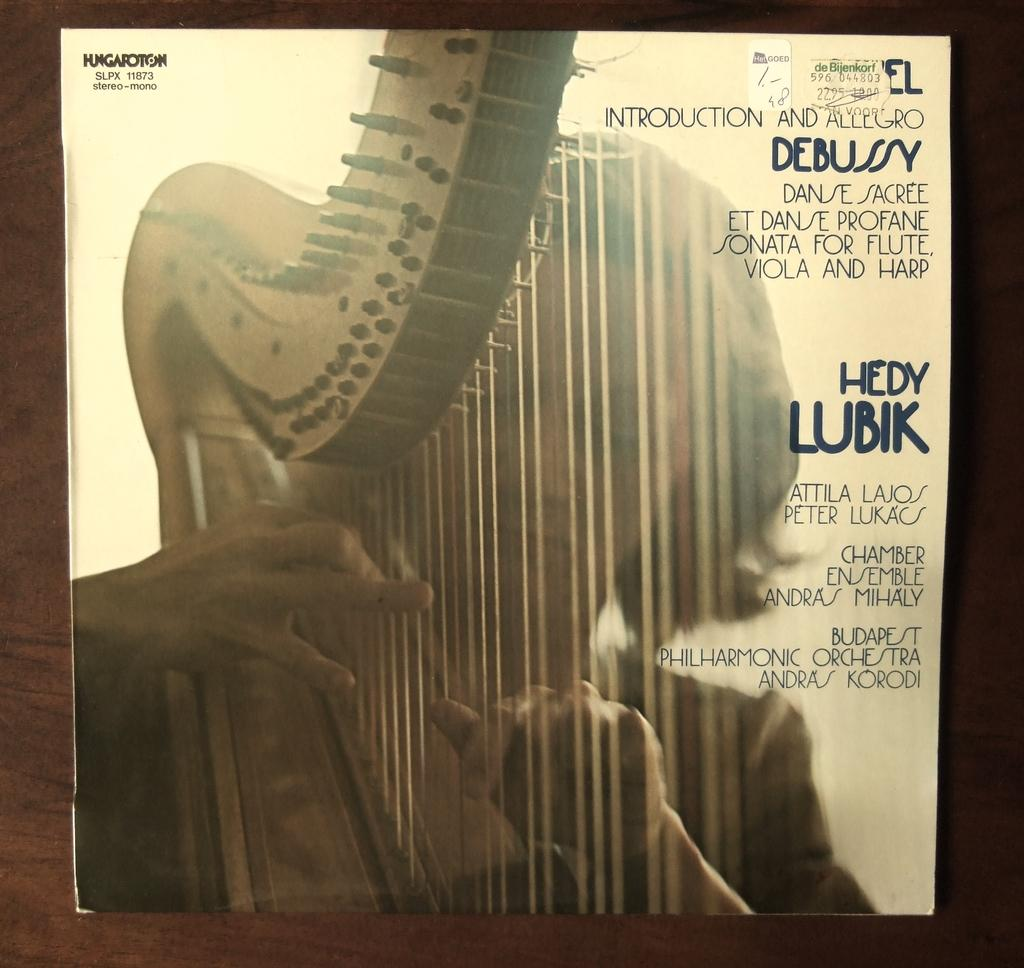What is the main subject of the image? There is a woman in the image. What is the woman holding in the image? The woman is holding a musical instrument. Is there any text present in the image? Yes, there is text written on the image. What color is the sweater the woman is wearing in the image? There is no mention of a sweater in the provided facts, so we cannot determine the color of a sweater the woman might be wearing. 